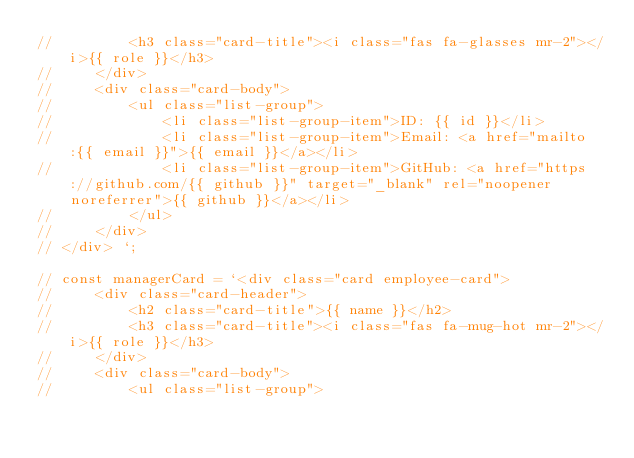Convert code to text. <code><loc_0><loc_0><loc_500><loc_500><_JavaScript_>//         <h3 class="card-title"><i class="fas fa-glasses mr-2"></i>{{ role }}</h3>
//     </div>
//     <div class="card-body">
//         <ul class="list-group">
//             <li class="list-group-item">ID: {{ id }}</li>
//             <li class="list-group-item">Email: <a href="mailto:{{ email }}">{{ email }}</a></li>
//             <li class="list-group-item">GitHub: <a href="https://github.com/{{ github }}" target="_blank" rel="noopener noreferrer">{{ github }}</a></li>
//         </ul>
//     </div>
// </div> `;

// const managerCard = `<div class="card employee-card">
//     <div class="card-header">
//         <h2 class="card-title">{{ name }}</h2>
//         <h3 class="card-title"><i class="fas fa-mug-hot mr-2"></i>{{ role }}</h3>
//     </div>
//     <div class="card-body">
//         <ul class="list-group"></code> 